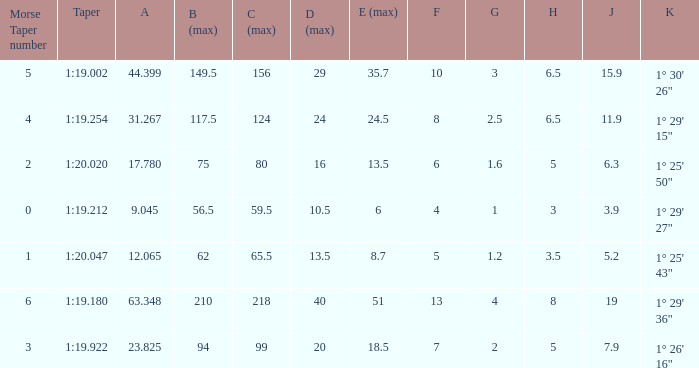Can you give me this table as a dict? {'header': ['Morse Taper number', 'Taper', 'A', 'B (max)', 'C (max)', 'D (max)', 'E (max)', 'F', 'G', 'H', 'J', 'K'], 'rows': [['5', '1:19.002', '44.399', '149.5', '156', '29', '35.7', '10', '3', '6.5', '15.9', '1° 30\' 26"'], ['4', '1:19.254', '31.267', '117.5', '124', '24', '24.5', '8', '2.5', '6.5', '11.9', '1° 29\' 15"'], ['2', '1:20.020', '17.780', '75', '80', '16', '13.5', '6', '1.6', '5', '6.3', '1° 25\' 50"'], ['0', '1:19.212', '9.045', '56.5', '59.5', '10.5', '6', '4', '1', '3', '3.9', '1° 29\' 27"'], ['1', '1:20.047', '12.065', '62', '65.5', '13.5', '8.7', '5', '1.2', '3.5', '5.2', '1° 25\' 43"'], ['6', '1:19.180', '63.348', '210', '218', '40', '51', '13', '4', '8', '19', '1° 29\' 36"'], ['3', '1:19.922', '23.825', '94', '99', '20', '18.5', '7', '2', '5', '7.9', '1° 26\' 16"']]} Name the least morse taper number when taper is 1:20.047 1.0. 